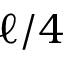Convert formula to latex. <formula><loc_0><loc_0><loc_500><loc_500>\ell / 4</formula> 